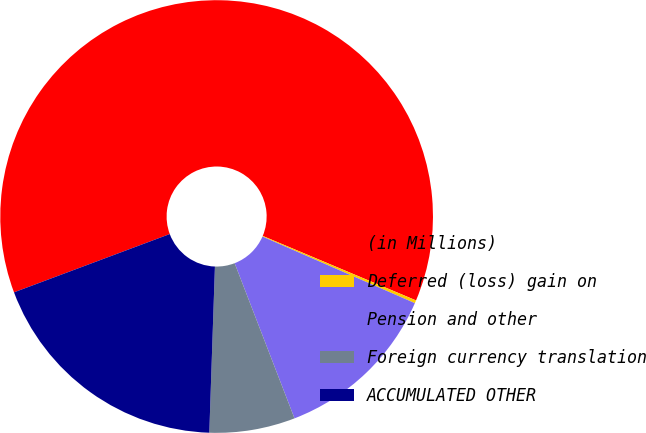Convert chart to OTSL. <chart><loc_0><loc_0><loc_500><loc_500><pie_chart><fcel>(in Millions)<fcel>Deferred (loss) gain on<fcel>Pension and other<fcel>Foreign currency translation<fcel>ACCUMULATED OTHER<nl><fcel>62.03%<fcel>0.22%<fcel>12.58%<fcel>6.4%<fcel>18.76%<nl></chart> 